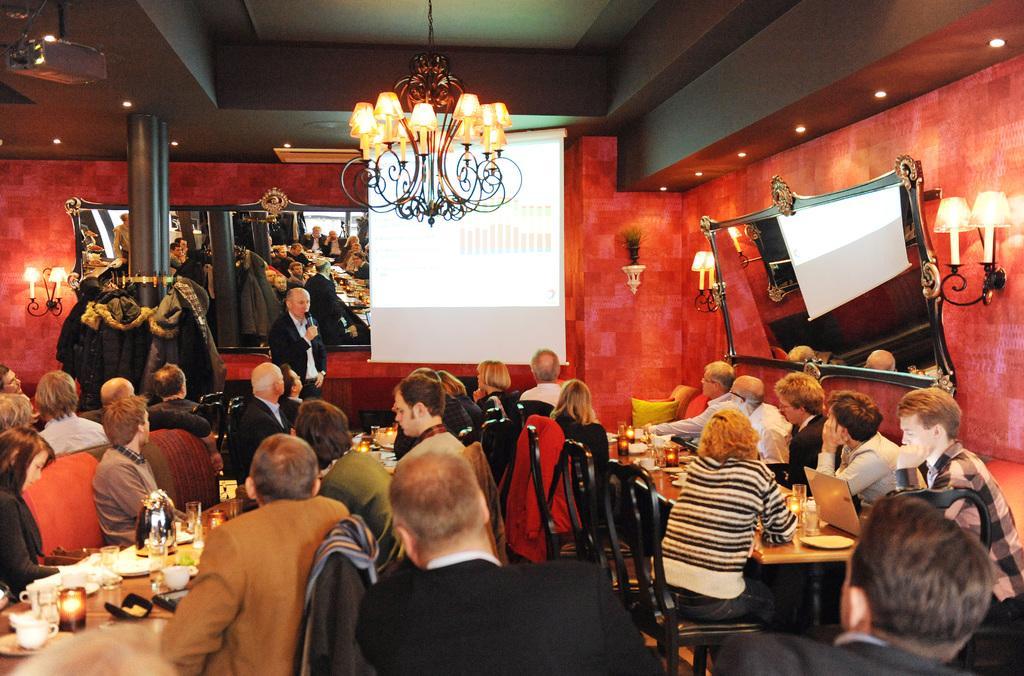Describe this image in one or two sentences. Here we can see people. Most of the people are sitting on chairs. In-front of them there are tables. On these tables there are glasses, cups, laptop and things. On these chairs there are jackets. Far a person is standing and holding a mic. Mirrors, lights and plant is on the red wall. Beside this chandelier light there is a screen. Here we can see projector. In mirror there is a reflection of screen, people and pillar. 